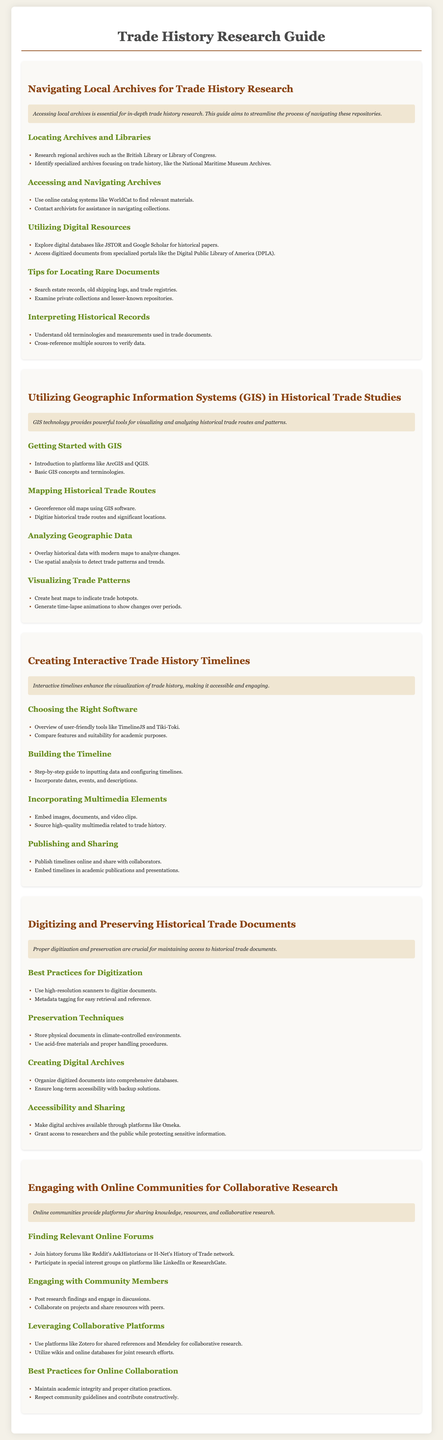What is the title of the guide? The title of the guide is mentioned at the top of the document.
Answer: Trade History Research Guide Which section discusses digitizing documents? The section titles provide information on topics covered in the document, which includes digitization.
Answer: Digitizing and Preserving Historical Trade Documents What software is recommended for creating timelines? The document lists user-friendly tools for interactive timelines.
Answer: TimelineJS and Tiki-Toki How many steps are outlined in the GIS section? The number of main headings in the GIS section indicates the steps covered.
Answer: Four What is the primary purpose of the online communities section? The introduction of the section states the significance of engaging in online communities.
Answer: Collaborative research Which type of archives should be researched for trade history? The guide indicates specific examples of archives important for trade history research.
Answer: Regional archives What is a key practice for preserving documents? The guide outlines preservation techniques necessary for maintaining access to historical documents.
Answer: Climate-controlled environments What type of resources does the guide mention for digitized documents? The digital resources section lists platforms for accessing digitized materials.
Answer: Digital Public Library of America 